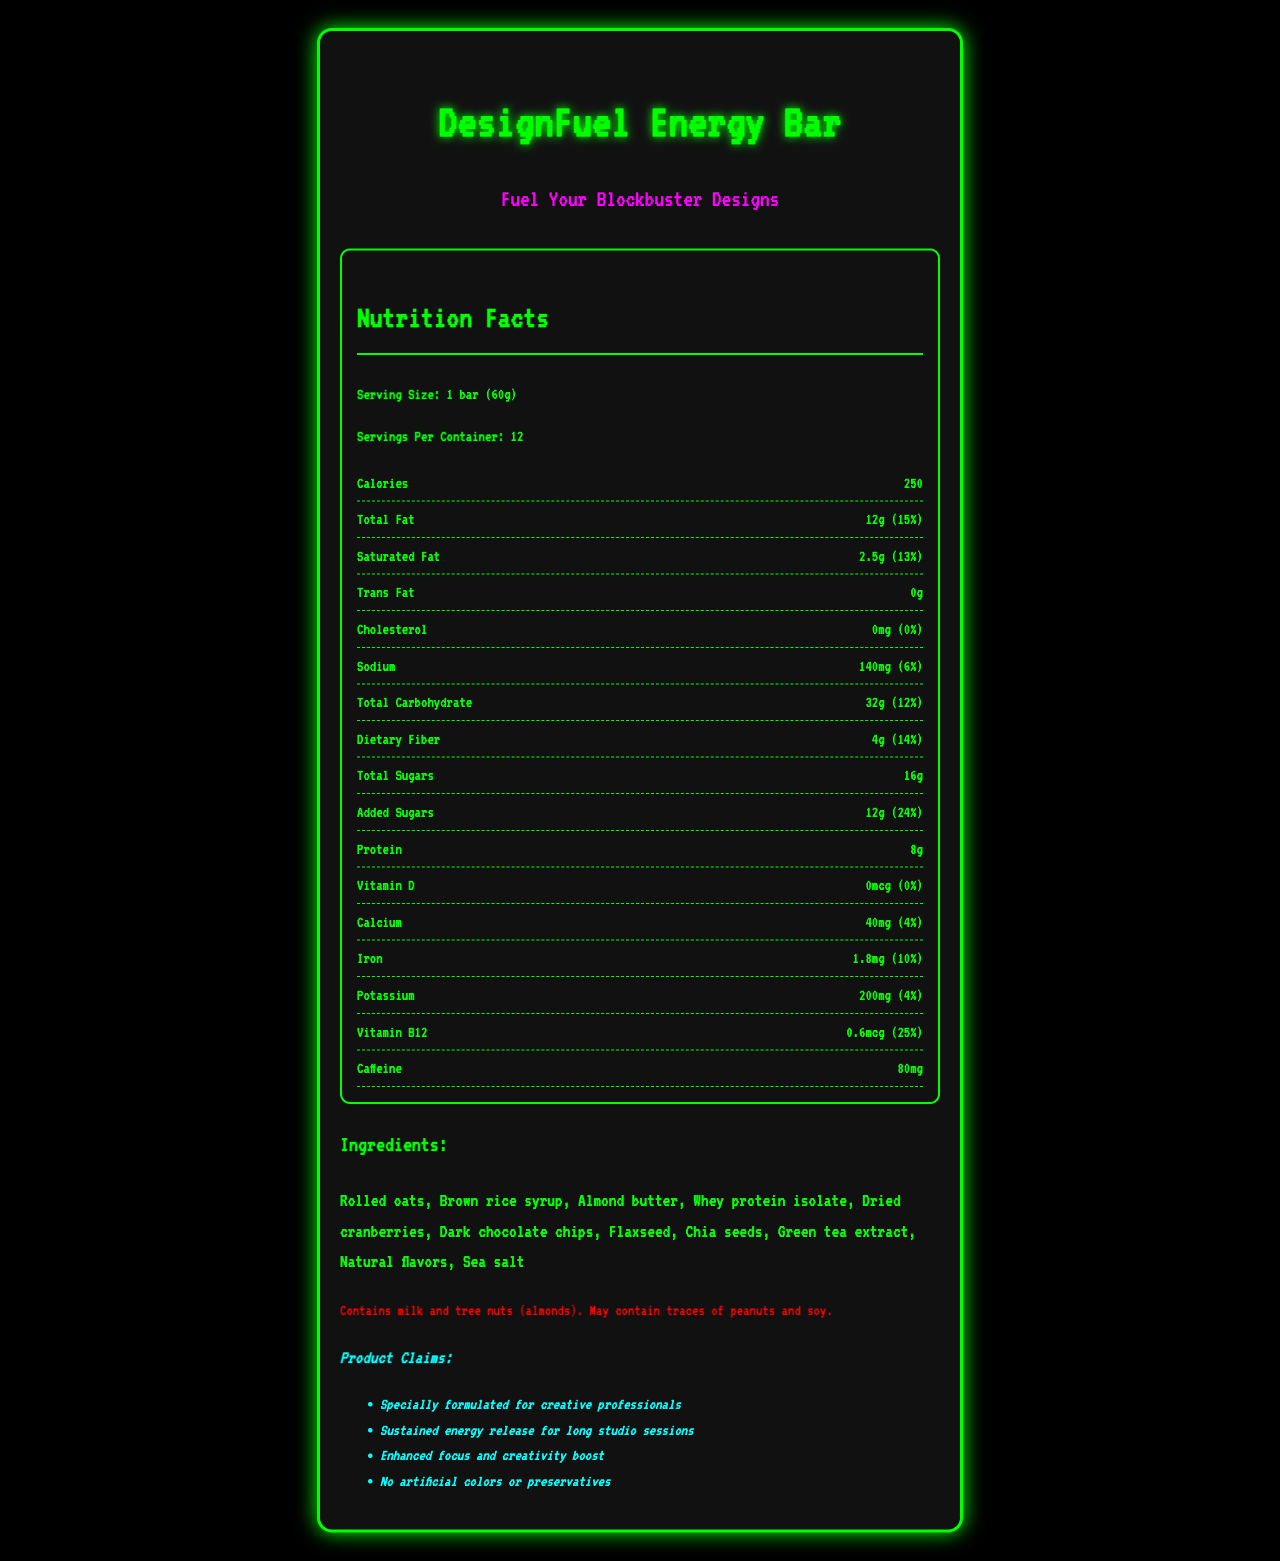what is the serving size for the DesignFuel Energy Bar? The serving size is explicitly mentioned in the document under the "Nutrition Facts" section as "1 bar (60g)".
Answer: 1 bar (60g) how many calories does one serving of the DesignFuel Energy Bar contain? The number of calories per serving is stated in the nutrition facts section as 250 calories.
Answer: 250 how much sodium is present in one serving of the bar? The sodium content per serving is listed in the Nutrition Facts as 140mg.
Answer: 140mg what are the total sugars in the DesignFuel Energy Bar? The total sugars are directly provided as 16g in the Nutrition Facts.
Answer: 16g what is the allergen information for the DesignFuel Energy Bar? The allergen information is clearly specified in the document.
Answer: Contains milk and tree nuts (almonds). May contain traces of peanuts and soy. which of the following ingredients is NOT listed in the DesignFuel Energy Bar? A. Green tea extract B. Peanut butter C. Dark chocolate chips D. Sea salt The ingredient list includes Green tea extract, Dark chocolate chips, and Sea salt, but not Peanut butter.
Answer: B what is the main flavor of the DesignFuel Energy Bar as per its tagline? A. Classic Almond B. Neon Berry Blast C. Chocolate Chip Delight D. Vanilla Swirl The retro-inspired flavor name mentioned in the document is "Neon Berry Blast."
Answer: B is there any cholesterol in the DesignFuel Energy Bar? The document states that the cholesterol content is 0mg, which means there’s no cholesterol in the bar.
Answer: No summarize the key elements of the DesignFuel Energy Bar as presented in the document. This explanation summarizes the nutritional information, ingredients, target audience, and additional product claims as outlined in the document.
Answer: The DesignFuel Energy Bar is a specially formulated energy bar aimed at creative professionals, providing sustained energy, enhanced focus, and creativity without artificial colors or preservatives. It contains notable ingredients like rolled oats, almond butter, and green tea extract, with a nutritional profile that includes 250 calories, 12g total fat, 8g protein, and 80mg caffeine per serving. It also features a high daily value of vitamin B12 (25%). The bar contains milk and almonds and may have traces of peanuts and soy. Its flavor is marketed as "Neon Berry Blast" with a tagline "Fuel Your Blockbuster Designs." how much caffeine does the DesignFuel Energy Bar contain? The caffeine content per serving is specifically listed as 80mg in the Nutrition Facts section.
Answer: 80mg can you determine the manufacturing date of the DesignFuel Energy Bar? The document does not provide any details about the manufacturing date, so it is impossible to determine this information.
Answer: Not enough information 